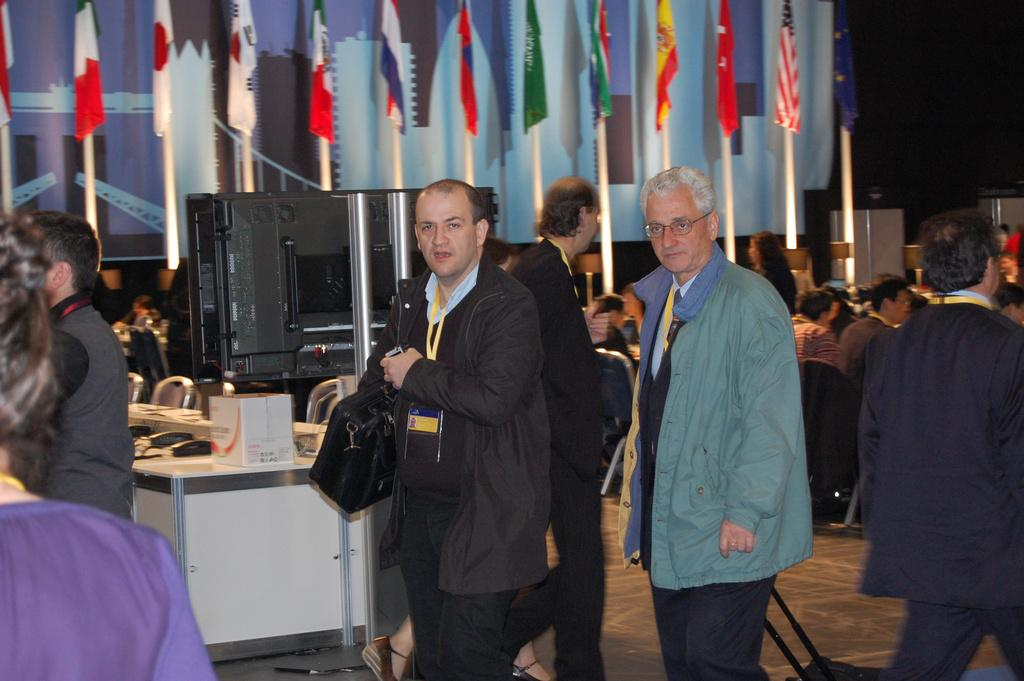What is the main subject of the image? The main subject of the image is a man walking in the middle of the image. What is the man wearing? The man is wearing a coat and trousers. Does the man have any identification in the image? Yes, the man has an ID card. What else can be seen in the image? There is another man moving on the right side of the image, and there are different country flags in the background of the image. What type of disgust can be seen on the man's face in the image? There is no indication of disgust on the man's face in the image. What shape is the yarn forming in the image? There is no yarn present in the image. 